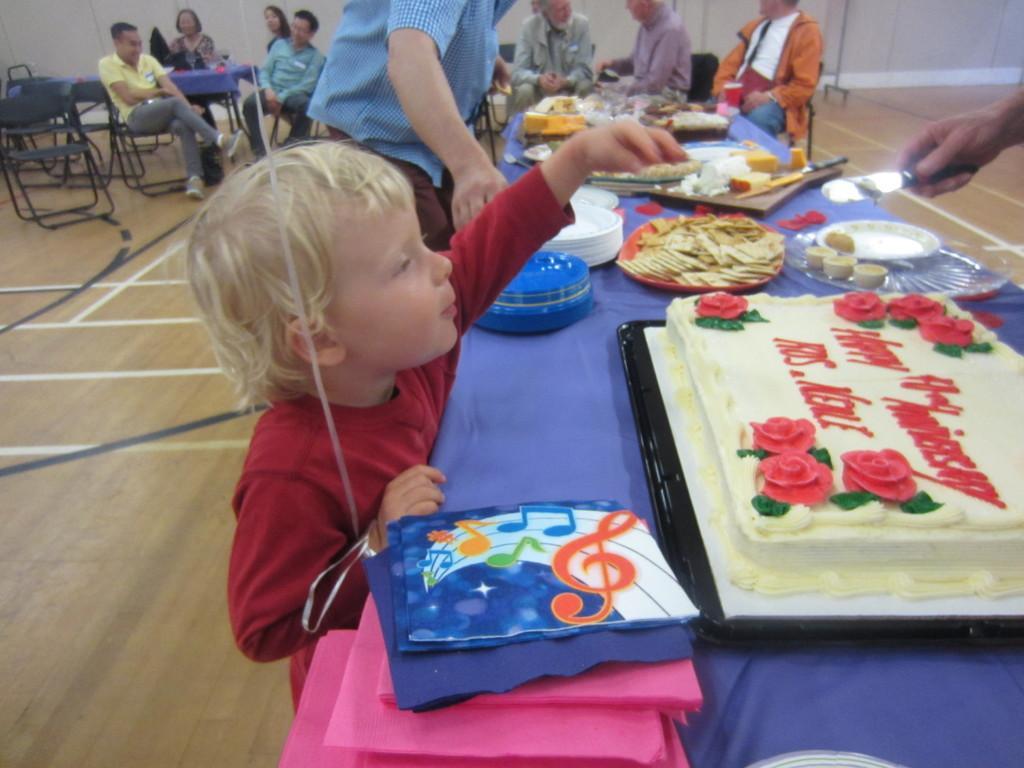Could you give a brief overview of what you see in this image? This picture shows few people seated on the chairs and a boy and a man standing and we see a cake and food on the table 